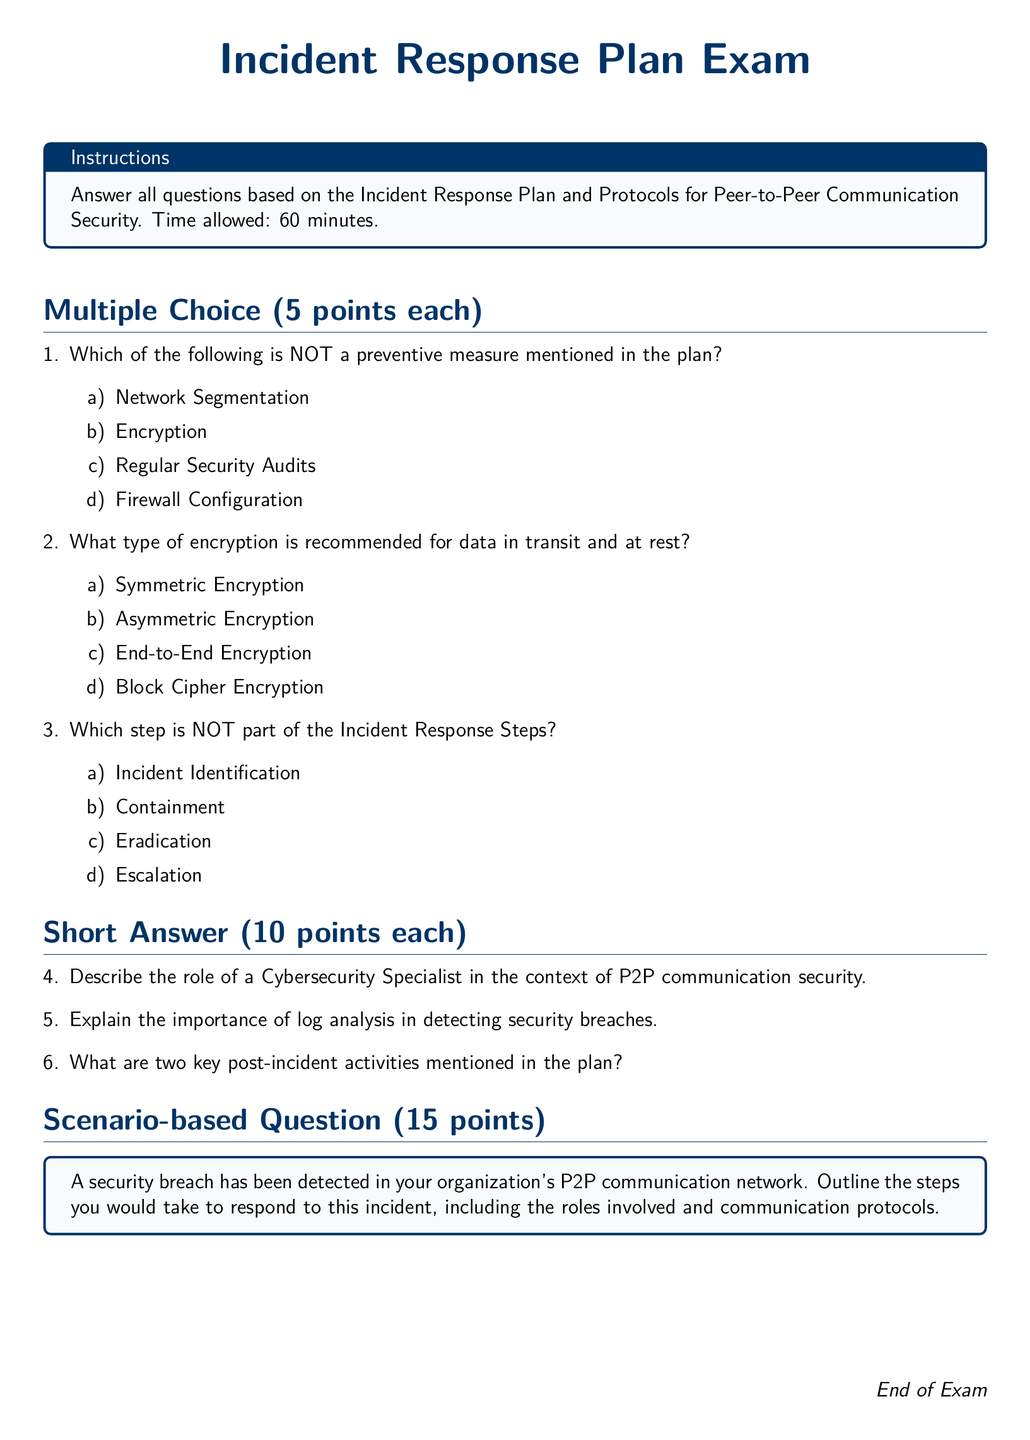What is the title of the document? The title is presented at the top center of the document, indicating the subject matter of the examination.
Answer: Incident Response Plan Exam How long is the time allowed for the exam? The time allowed is specified in the instructions section of the document.
Answer: 60 minutes How many points is each multiple-choice question worth? The point value for each question type is outlined in the corresponding sections of the document.
Answer: 5 points What is required for data protection during transit and at rest? The recommended method for securing data is clearly mentioned in the options presented.
Answer: End-to-End Encryption Name one of the key post-incident activities mentioned in the plan. The answer can be retrieved from the context referring to the incident response activities detailed in the short answer questions.
Answer: (Any one of the two key post-incident activities) What is the first step in the Incident Response Steps? The steps are listed under a specific section, indicating the sequence of the incident response process.
Answer: Incident Identification In which section can you find the scenario-based question? The structure of the document indicates where the scenario-based question is presented.
Answer: Scenario-based Question What color is used for the background of the instructions box? The specific colors for document elements are defined in the color specifications.
Answer: Light blue Which type of encryption is generally recommended in the plan? The preferred encryption method is provided among the multiple-choice options in the exam.
Answer: End-to-End Encryption 